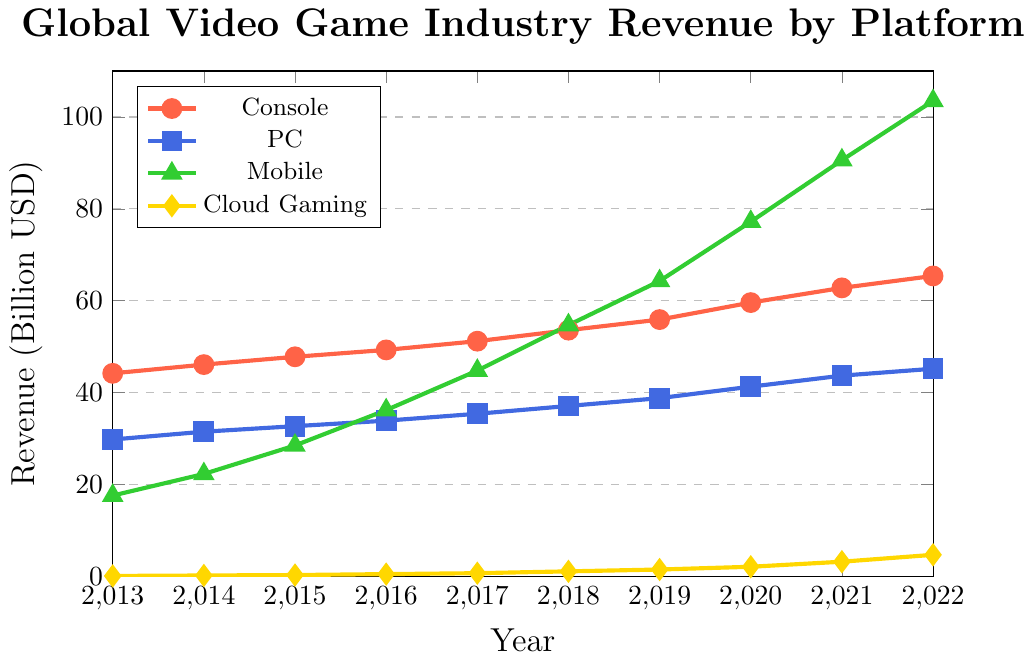What's the revenue difference between Console and Mobile platforms in 2016? The revenue for Console in 2016 is 49.3 billion USD, and for Mobile, it is 36.2 billion USD. The difference is 49.3 - 36.2.
Answer: 13.1 billion USD Which platform experienced the highest revenue growth from 2013 to 2022? Mobile revenue in 2013 was 17.6 billion USD and in 2022 it was 103.5 billion USD. The growth is 103.5 - 17.6 = 85.9 billion USD.
Answer: Mobile What is the total revenue of all platforms in 2020? Adding the revenue of Console, PC, Mobile, and Cloud Gaming in 2020: 59.6 + 41.3 + 77.2 + 2.1 = 180.2 billion USD.
Answer: 180.2 billion USD In which year did the PC platform surpass 40 billion USD in revenue? From the plot, the PC platform revenue is 41.3 billion USD in 2020, so it first surpasses 40 billion USD in 2020.
Answer: 2020 Between PC and Console, which had a higher revenue in 2017? The revenue for Console in 2017 is 51.2 billion USD, and for PC, it is 35.4 billion USD; therefore, Console had higher revenue.
Answer: Console What is the approximate average annual revenue for Cloud Gaming over the period shown? Summing the annual revenues for Cloud Gaming from 2013 to 2022: 0.1 + 0.2 + 0.3 + 0.5 + 0.7 + 1.1 + 1.5 + 2.1 + 3.2 + 4.7 = 14.4 billion USD. Dividing by the number of years (10) gives 14.4 / 10 = 1.44 billion USD.
Answer: 1.44 billion USD During what year did Mobile revenue exceed PC revenue? In 2016, Mobile revenue is 36.2 billion USD compared to PC's 33.9 billion USD.
Answer: 2016 By how much did Cloud Gaming revenue increase from 2015 to 2022? Cloud Gaming revenue in 2015 was 0.3 billion USD and in 2022 it was 4.7 billion USD. The increase is 4.7 - 0.3 = 4.4 billion USD.
Answer: 4.4 billion USD What color represents the Console revenue trend line? The Console revenue trend line is represented by a red color.
Answer: Red 